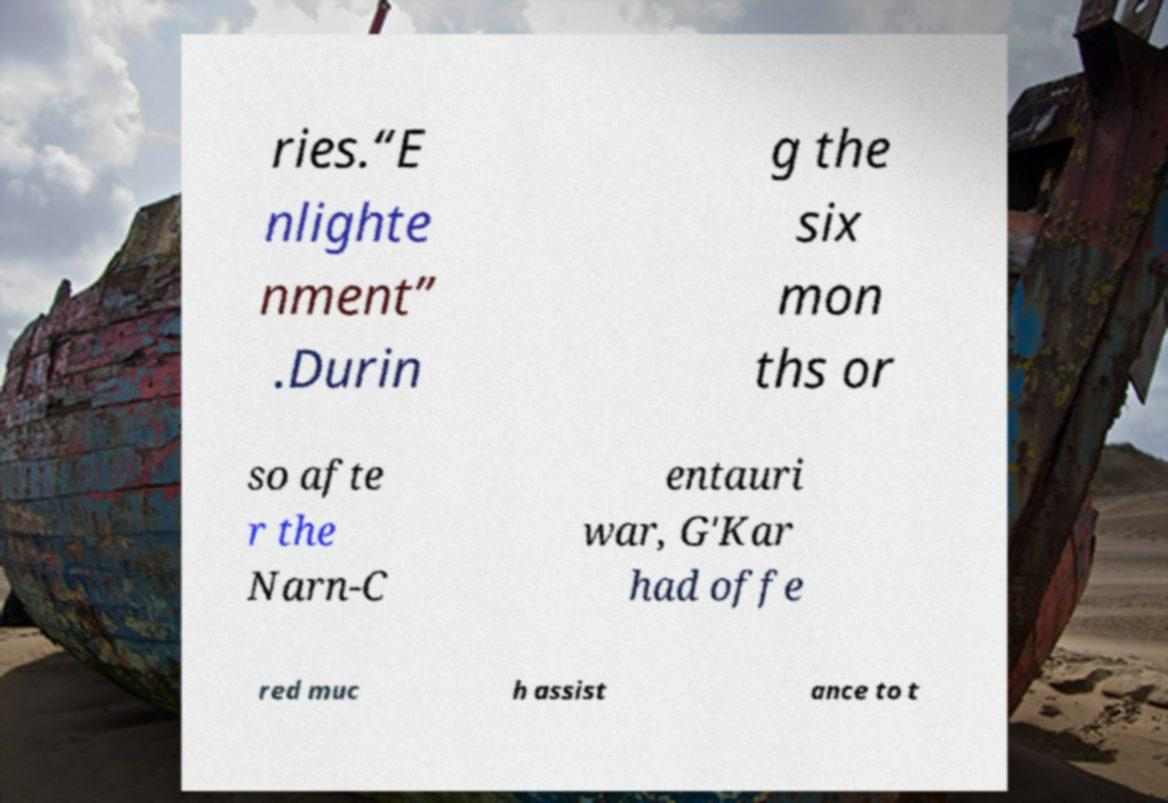I need the written content from this picture converted into text. Can you do that? ries.“E nlighte nment” .Durin g the six mon ths or so afte r the Narn-C entauri war, G'Kar had offe red muc h assist ance to t 